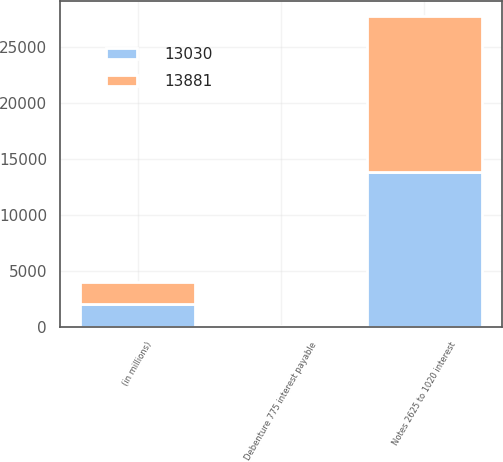Convert chart to OTSL. <chart><loc_0><loc_0><loc_500><loc_500><stacked_bar_chart><ecel><fcel>(in millions)<fcel>Notes 2625 to 1020 interest<fcel>Debenture 775 interest payable<nl><fcel>13881<fcel>2017<fcel>13852<fcel>42<nl><fcel>13030<fcel>2016<fcel>13839<fcel>42<nl></chart> 